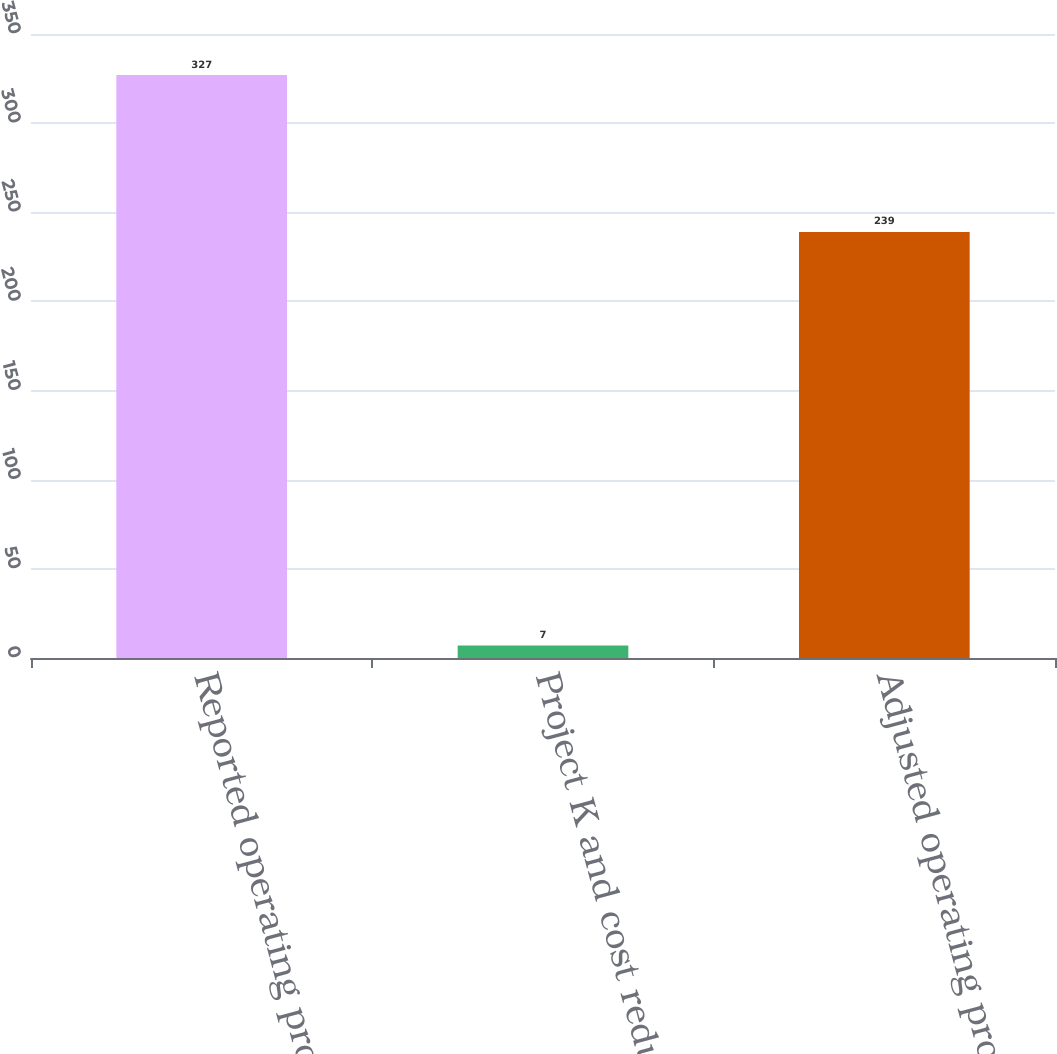Convert chart to OTSL. <chart><loc_0><loc_0><loc_500><loc_500><bar_chart><fcel>Reported operating profit<fcel>Project K and cost reduction<fcel>Adjusted operating profit<nl><fcel>327<fcel>7<fcel>239<nl></chart> 